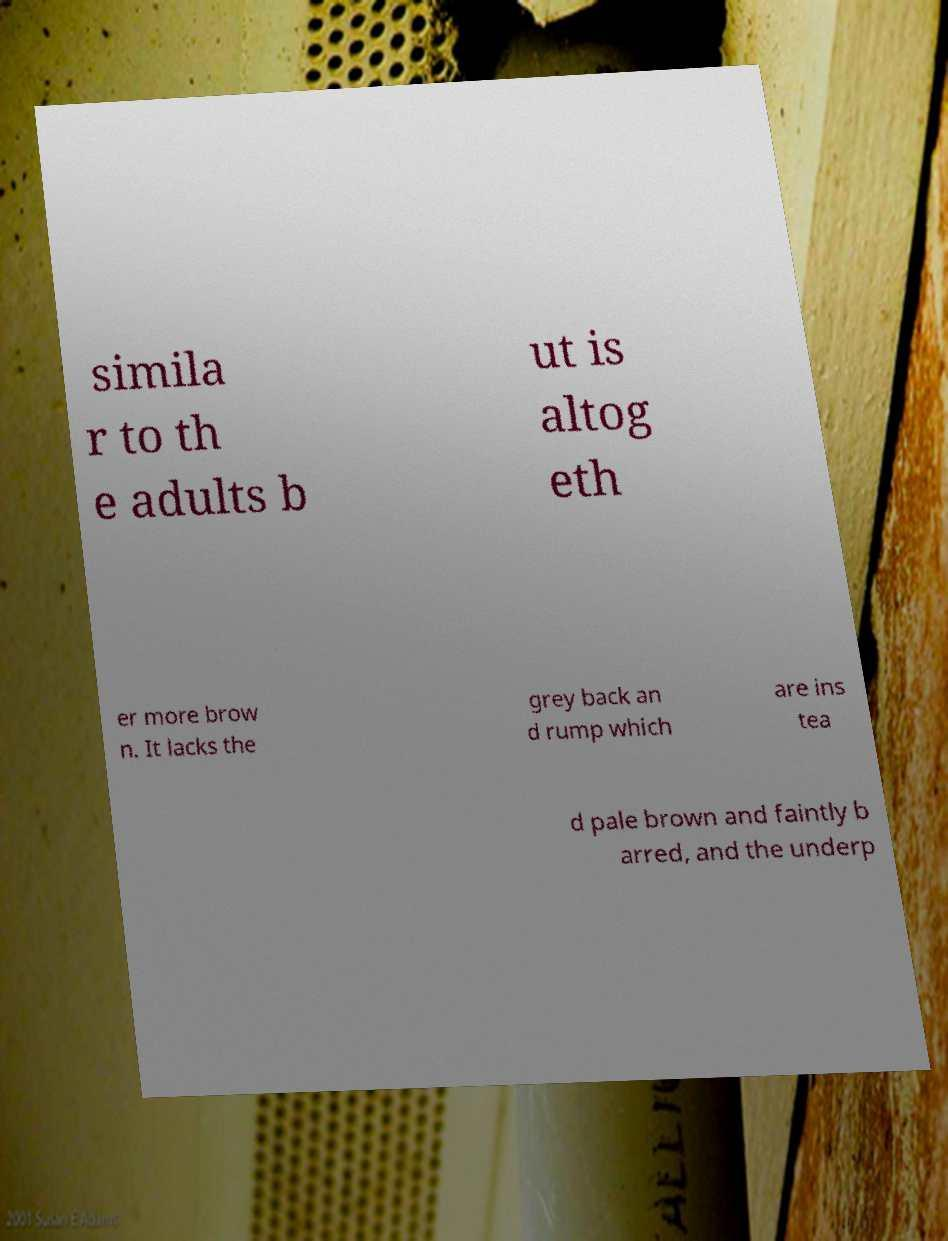Could you assist in decoding the text presented in this image and type it out clearly? simila r to th e adults b ut is altog eth er more brow n. It lacks the grey back an d rump which are ins tea d pale brown and faintly b arred, and the underp 